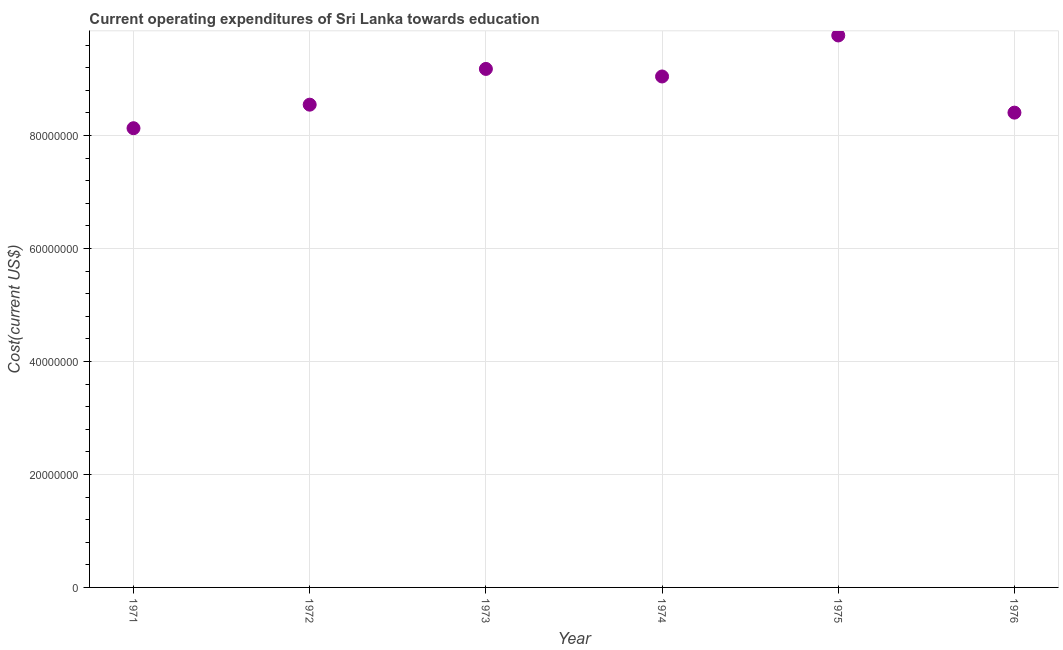What is the education expenditure in 1972?
Keep it short and to the point. 8.55e+07. Across all years, what is the maximum education expenditure?
Offer a very short reply. 9.77e+07. Across all years, what is the minimum education expenditure?
Your answer should be compact. 8.13e+07. In which year was the education expenditure maximum?
Your answer should be very brief. 1975. What is the sum of the education expenditure?
Provide a succinct answer. 5.31e+08. What is the difference between the education expenditure in 1972 and 1975?
Give a very brief answer. -1.23e+07. What is the average education expenditure per year?
Offer a very short reply. 8.85e+07. What is the median education expenditure?
Your answer should be very brief. 8.80e+07. Do a majority of the years between 1976 and 1971 (inclusive) have education expenditure greater than 28000000 US$?
Provide a short and direct response. Yes. What is the ratio of the education expenditure in 1973 to that in 1976?
Give a very brief answer. 1.09. Is the education expenditure in 1972 less than that in 1974?
Provide a short and direct response. Yes. What is the difference between the highest and the second highest education expenditure?
Provide a short and direct response. 5.92e+06. What is the difference between the highest and the lowest education expenditure?
Provide a succinct answer. 1.64e+07. In how many years, is the education expenditure greater than the average education expenditure taken over all years?
Provide a succinct answer. 3. How many years are there in the graph?
Keep it short and to the point. 6. What is the difference between two consecutive major ticks on the Y-axis?
Keep it short and to the point. 2.00e+07. Does the graph contain grids?
Your answer should be compact. Yes. What is the title of the graph?
Your response must be concise. Current operating expenditures of Sri Lanka towards education. What is the label or title of the Y-axis?
Provide a succinct answer. Cost(current US$). What is the Cost(current US$) in 1971?
Give a very brief answer. 8.13e+07. What is the Cost(current US$) in 1972?
Provide a succinct answer. 8.55e+07. What is the Cost(current US$) in 1973?
Your response must be concise. 9.18e+07. What is the Cost(current US$) in 1974?
Make the answer very short. 9.05e+07. What is the Cost(current US$) in 1975?
Make the answer very short. 9.77e+07. What is the Cost(current US$) in 1976?
Your response must be concise. 8.40e+07. What is the difference between the Cost(current US$) in 1971 and 1972?
Provide a succinct answer. -4.17e+06. What is the difference between the Cost(current US$) in 1971 and 1973?
Offer a terse response. -1.05e+07. What is the difference between the Cost(current US$) in 1971 and 1974?
Your answer should be very brief. -9.16e+06. What is the difference between the Cost(current US$) in 1971 and 1975?
Your answer should be very brief. -1.64e+07. What is the difference between the Cost(current US$) in 1971 and 1976?
Your response must be concise. -2.76e+06. What is the difference between the Cost(current US$) in 1972 and 1973?
Give a very brief answer. -6.33e+06. What is the difference between the Cost(current US$) in 1972 and 1974?
Provide a succinct answer. -4.99e+06. What is the difference between the Cost(current US$) in 1972 and 1975?
Provide a succinct answer. -1.23e+07. What is the difference between the Cost(current US$) in 1972 and 1976?
Give a very brief answer. 1.41e+06. What is the difference between the Cost(current US$) in 1973 and 1974?
Offer a terse response. 1.34e+06. What is the difference between the Cost(current US$) in 1973 and 1975?
Offer a very short reply. -5.92e+06. What is the difference between the Cost(current US$) in 1973 and 1976?
Ensure brevity in your answer.  7.74e+06. What is the difference between the Cost(current US$) in 1974 and 1975?
Offer a very short reply. -7.26e+06. What is the difference between the Cost(current US$) in 1974 and 1976?
Provide a succinct answer. 6.40e+06. What is the difference between the Cost(current US$) in 1975 and 1976?
Your response must be concise. 1.37e+07. What is the ratio of the Cost(current US$) in 1971 to that in 1972?
Your answer should be compact. 0.95. What is the ratio of the Cost(current US$) in 1971 to that in 1973?
Provide a succinct answer. 0.89. What is the ratio of the Cost(current US$) in 1971 to that in 1974?
Ensure brevity in your answer.  0.9. What is the ratio of the Cost(current US$) in 1971 to that in 1975?
Provide a succinct answer. 0.83. What is the ratio of the Cost(current US$) in 1971 to that in 1976?
Provide a short and direct response. 0.97. What is the ratio of the Cost(current US$) in 1972 to that in 1974?
Offer a terse response. 0.94. What is the ratio of the Cost(current US$) in 1972 to that in 1975?
Your answer should be very brief. 0.88. What is the ratio of the Cost(current US$) in 1973 to that in 1974?
Offer a terse response. 1.01. What is the ratio of the Cost(current US$) in 1973 to that in 1975?
Provide a short and direct response. 0.94. What is the ratio of the Cost(current US$) in 1973 to that in 1976?
Your answer should be compact. 1.09. What is the ratio of the Cost(current US$) in 1974 to that in 1975?
Offer a terse response. 0.93. What is the ratio of the Cost(current US$) in 1974 to that in 1976?
Your answer should be very brief. 1.08. What is the ratio of the Cost(current US$) in 1975 to that in 1976?
Your answer should be very brief. 1.16. 